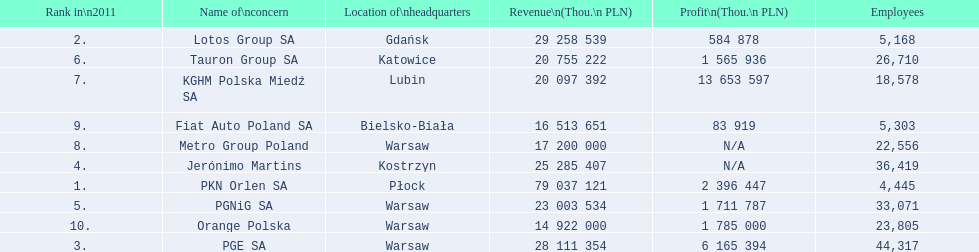Which concern's headquarters are located in warsaw? PGE SA, PGNiG SA, Metro Group Poland. Which of these listed a profit? PGE SA, PGNiG SA. Of these how many employees are in the concern with the lowest profit? 33,071. 